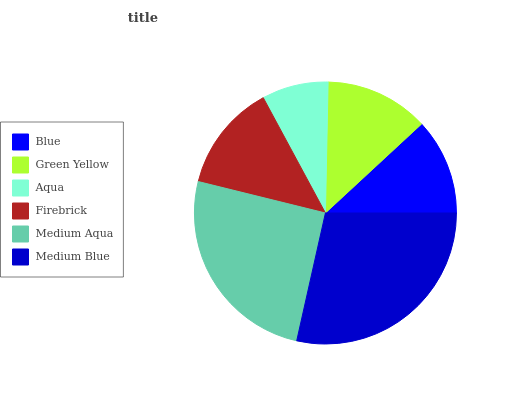Is Aqua the minimum?
Answer yes or no. Yes. Is Medium Blue the maximum?
Answer yes or no. Yes. Is Green Yellow the minimum?
Answer yes or no. No. Is Green Yellow the maximum?
Answer yes or no. No. Is Green Yellow greater than Blue?
Answer yes or no. Yes. Is Blue less than Green Yellow?
Answer yes or no. Yes. Is Blue greater than Green Yellow?
Answer yes or no. No. Is Green Yellow less than Blue?
Answer yes or no. No. Is Firebrick the high median?
Answer yes or no. Yes. Is Green Yellow the low median?
Answer yes or no. Yes. Is Blue the high median?
Answer yes or no. No. Is Aqua the low median?
Answer yes or no. No. 